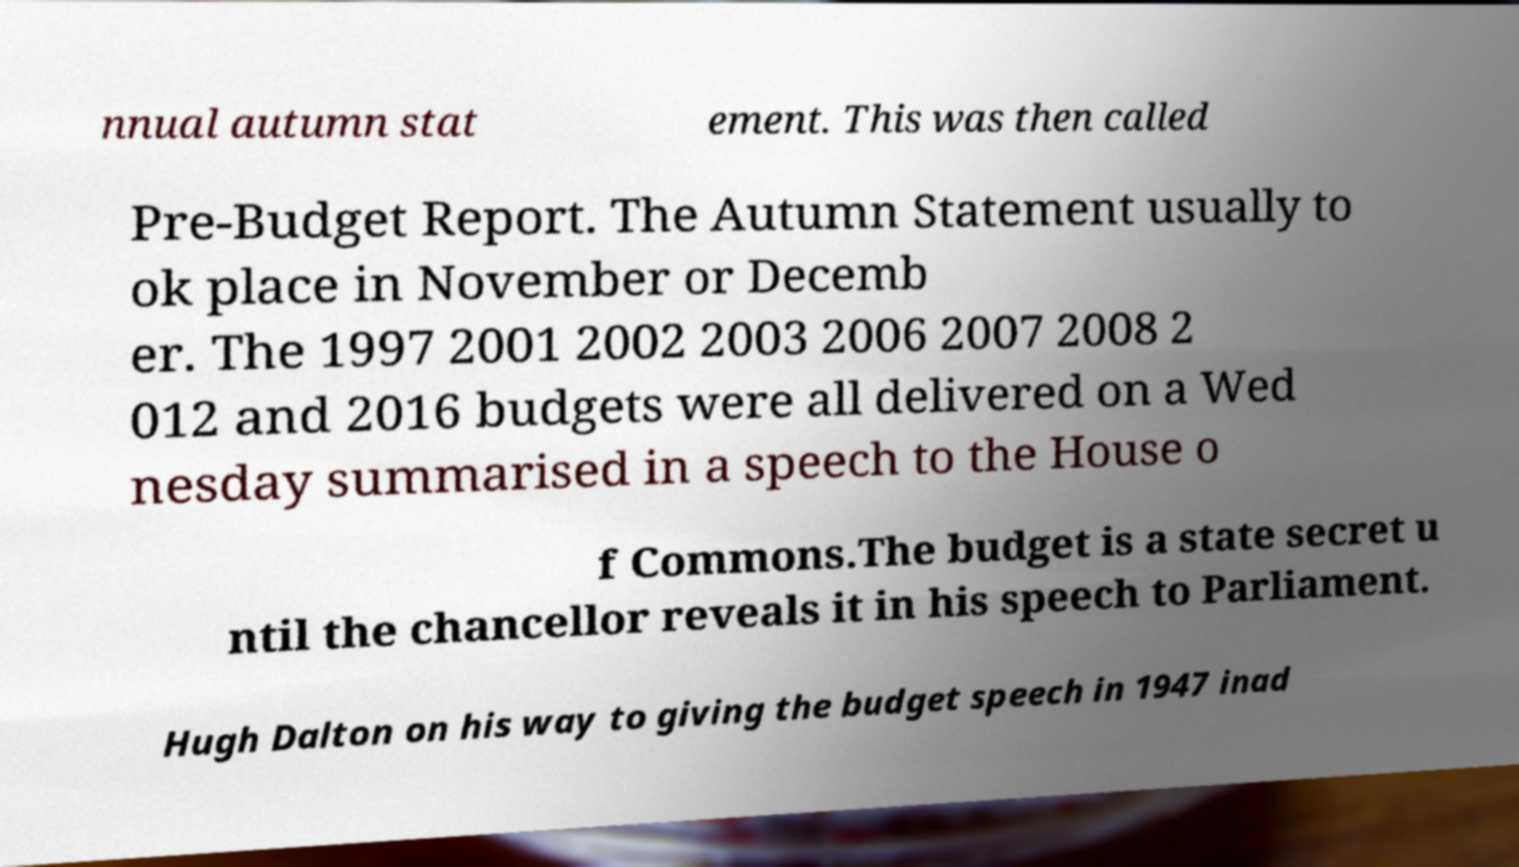I need the written content from this picture converted into text. Can you do that? nnual autumn stat ement. This was then called Pre-Budget Report. The Autumn Statement usually to ok place in November or Decemb er. The 1997 2001 2002 2003 2006 2007 2008 2 012 and 2016 budgets were all delivered on a Wed nesday summarised in a speech to the House o f Commons.The budget is a state secret u ntil the chancellor reveals it in his speech to Parliament. Hugh Dalton on his way to giving the budget speech in 1947 inad 